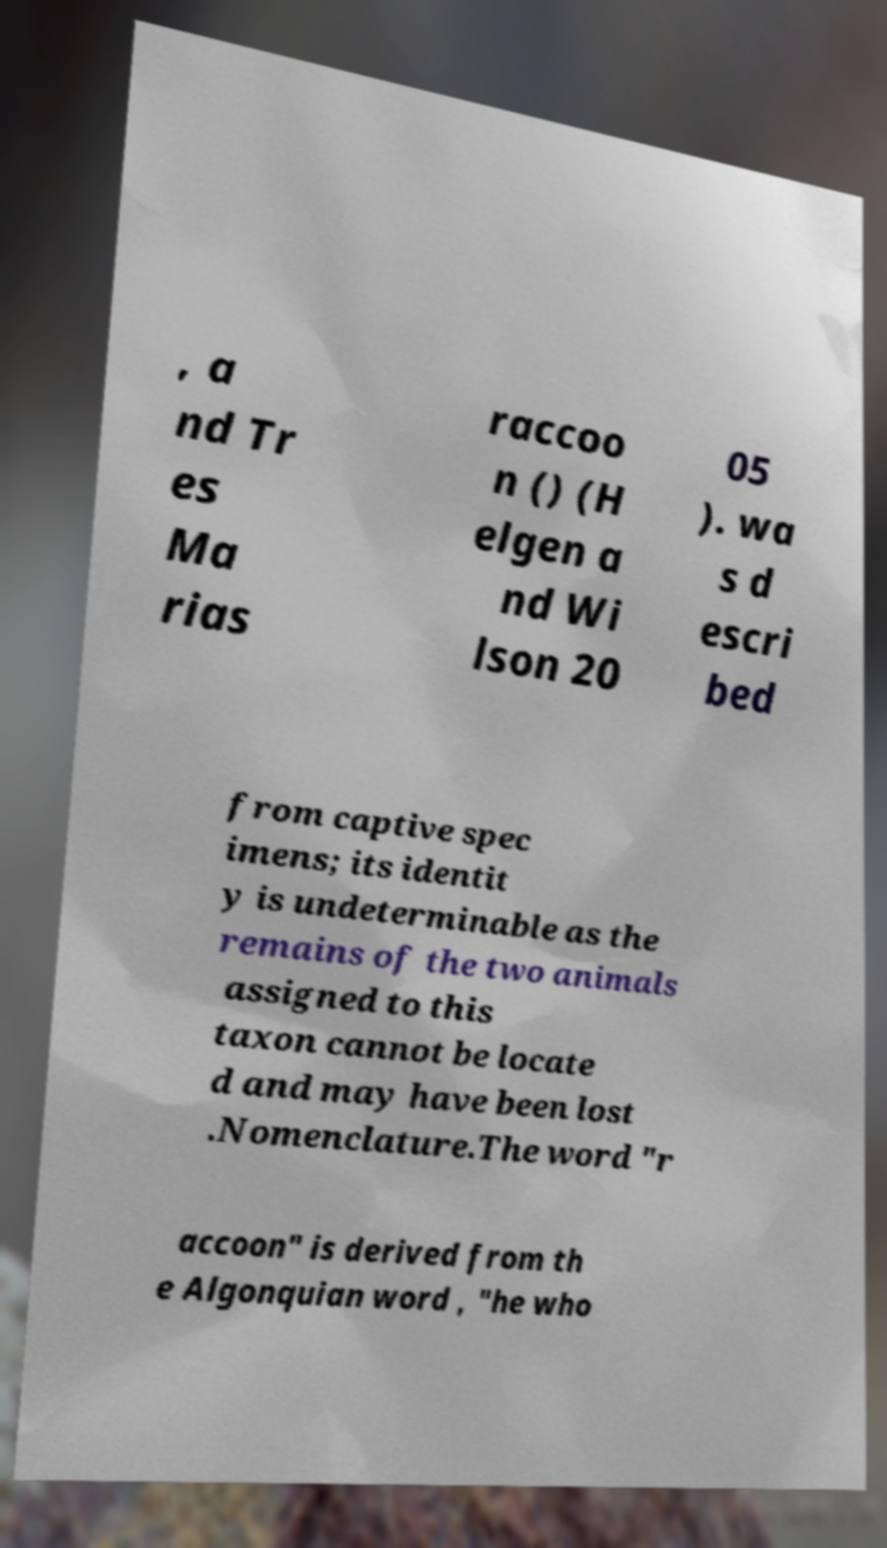What messages or text are displayed in this image? I need them in a readable, typed format. , a nd Tr es Ma rias raccoo n () (H elgen a nd Wi lson 20 05 ). wa s d escri bed from captive spec imens; its identit y is undeterminable as the remains of the two animals assigned to this taxon cannot be locate d and may have been lost .Nomenclature.The word "r accoon" is derived from th e Algonquian word , "he who 